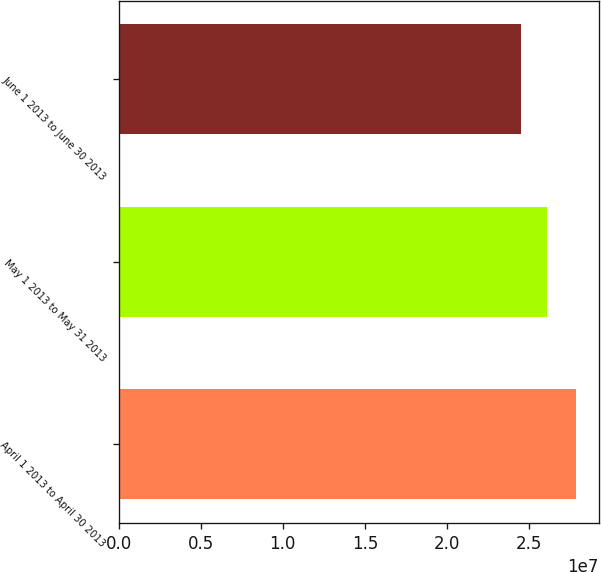Convert chart to OTSL. <chart><loc_0><loc_0><loc_500><loc_500><bar_chart><fcel>April 1 2013 to April 30 2013<fcel>May 1 2013 to May 31 2013<fcel>June 1 2013 to June 30 2013<nl><fcel>2.7879e+07<fcel>2.60914e+07<fcel>2.45322e+07<nl></chart> 